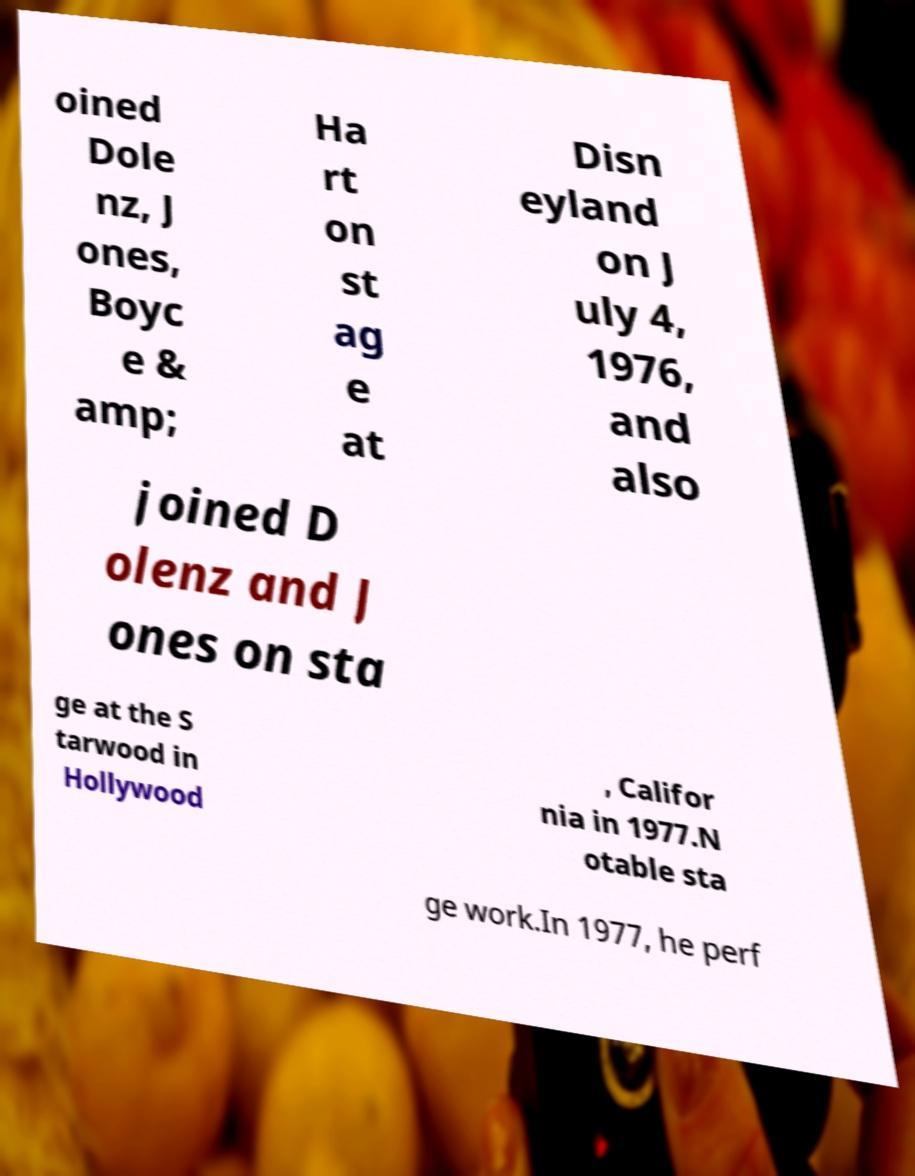Can you accurately transcribe the text from the provided image for me? oined Dole nz, J ones, Boyc e & amp; Ha rt on st ag e at Disn eyland on J uly 4, 1976, and also joined D olenz and J ones on sta ge at the S tarwood in Hollywood , Califor nia in 1977.N otable sta ge work.In 1977, he perf 